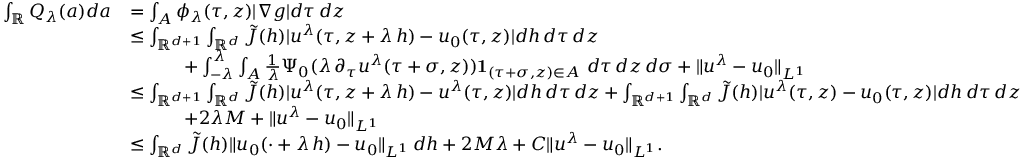<formula> <loc_0><loc_0><loc_500><loc_500>\begin{array} { r l } { \int _ { \mathbb { R } } Q _ { \lambda } ( a ) d a } & { = \int _ { A } \phi _ { \lambda } ( \tau , z ) | \nabla g | d \tau \, d z } \\ & { \leq \int _ { \mathbb { R } ^ { d + 1 } } \int _ { \mathbb { R } ^ { d } } \tilde { J } ( h ) | u ^ { \lambda } ( \tau , z + \lambda \, h ) - u _ { 0 } ( \tau , z ) | d h \, d \tau \, d z } \\ & { \quad + \int _ { - \lambda } ^ { \lambda } \int _ { A } \frac { 1 } { \lambda } \Psi _ { 0 } ( \lambda \, \partial _ { \tau } u ^ { \lambda } ( \tau + \sigma , z ) ) { 1 } _ { ( \tau + \sigma , z ) \in A } \ d \tau \, d z \, d \sigma + \| u ^ { \lambda } - u _ { 0 } \| _ { L ^ { 1 } } } \\ & { \leq \int _ { \mathbb { R } ^ { d + 1 } } \int _ { \mathbb { R } ^ { d } } \tilde { J } ( h ) | u ^ { \lambda } ( \tau , z + \lambda \, h ) - u ^ { \lambda } ( \tau , z ) | d h \, d \tau \, d z + \int _ { \mathbb { R } ^ { d + 1 } } \int _ { \mathbb { R } ^ { d } } \tilde { J } ( h ) | u ^ { \lambda } ( \tau , z ) - u _ { 0 } ( \tau , z ) | d h \, d \tau \, d z } \\ & { \quad + 2 \lambda M + \| u ^ { \lambda } - u _ { 0 } \| _ { L ^ { 1 } } } \\ & { \leq \int _ { \mathbb { R } ^ { d } } \tilde { J } ( h ) \| u _ { 0 } ( \cdot + \lambda \, h ) - u _ { 0 } \| _ { L ^ { 1 } } \, d h + 2 M \lambda + C \| u ^ { \lambda } - u _ { 0 } \| _ { L ^ { 1 } } . } \end{array}</formula> 